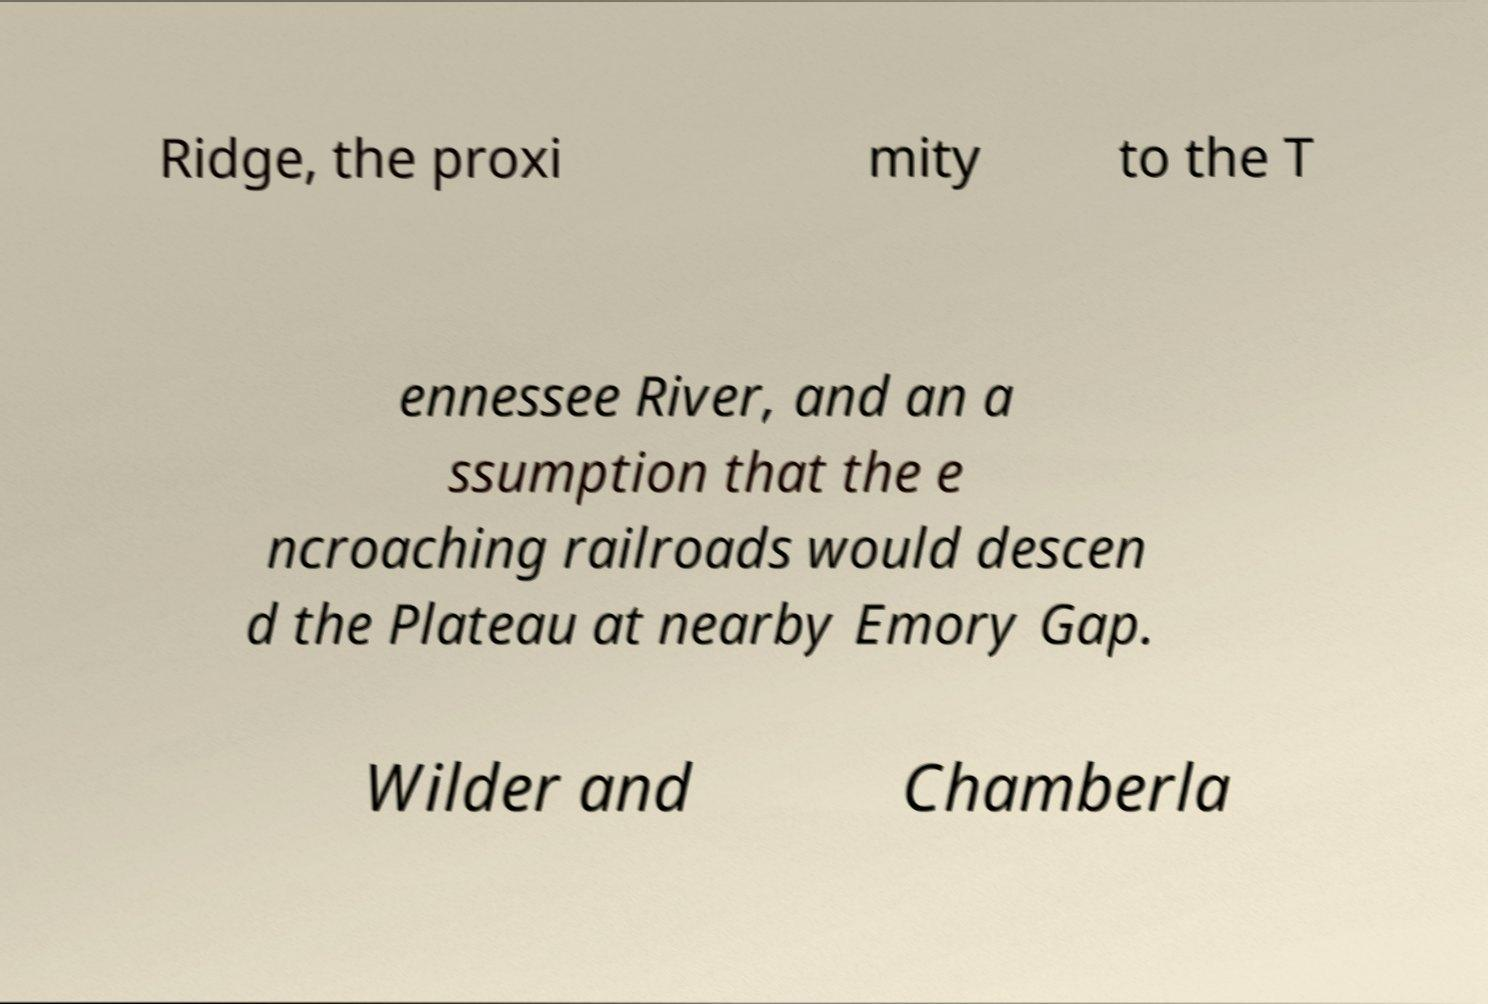For documentation purposes, I need the text within this image transcribed. Could you provide that? Ridge, the proxi mity to the T ennessee River, and an a ssumption that the e ncroaching railroads would descen d the Plateau at nearby Emory Gap. Wilder and Chamberla 